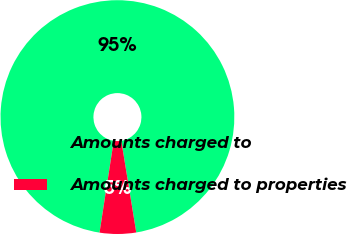Convert chart. <chart><loc_0><loc_0><loc_500><loc_500><pie_chart><fcel>Amounts charged to<fcel>Amounts charged to properties<nl><fcel>94.98%<fcel>5.02%<nl></chart> 